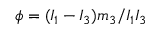<formula> <loc_0><loc_0><loc_500><loc_500>\phi = ( I _ { 1 } - I _ { 3 } ) m _ { 3 } / I _ { 1 } I _ { 3 }</formula> 